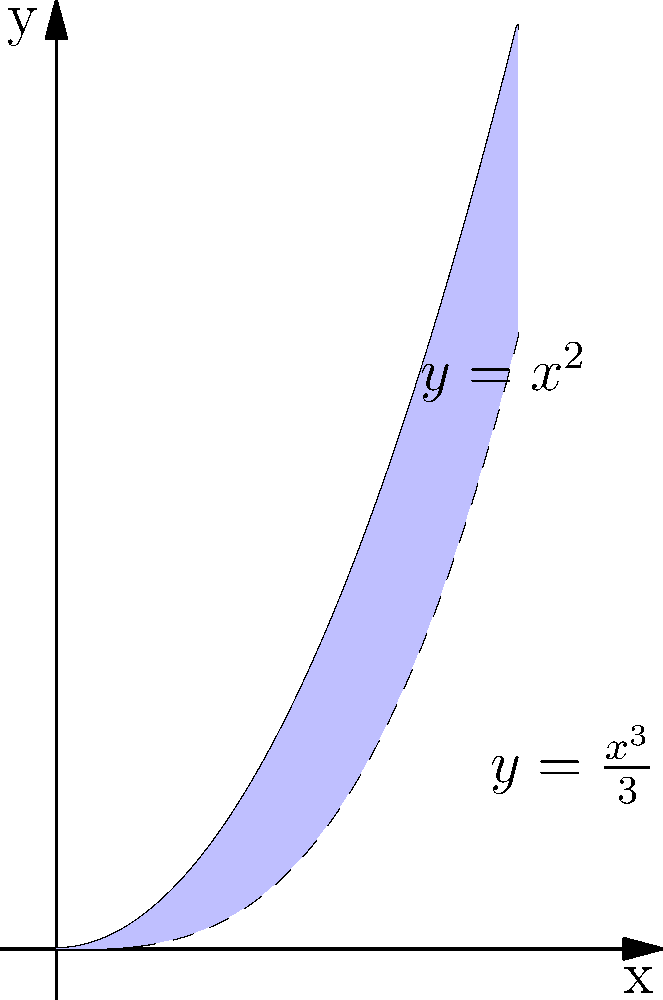As an NLP developer working on mathematical language processing, you're implementing a feature to compute areas between curves. Given the polynomial functions $f(x)=x^2$ and $g(x)=\frac{x^3}{3}$, calculate the area between these curves from $x=0$ to $x=2$. How would you approach this problem programmatically, and what is the resulting area? To find the area between two polynomial curves, we follow these steps:

1) Identify the upper and lower functions:
   $f(x) = x^2$ (upper function)
   $g(x) = \frac{x^3}{3}$ (lower function)

2) Set up the integral:
   Area = $\int_0^2 [f(x) - g(x)] dx$

3) Substitute the functions:
   Area = $\int_0^2 [x^2 - \frac{x^3}{3}] dx$

4) Integrate:
   Area = $[\frac{x^3}{3} - \frac{x^4}{12}]_0^2$

5) Evaluate the integral:
   Area = $[(\frac{2^3}{3} - \frac{2^4}{12}) - (0 - 0)]$
        = $[\frac{8}{3} - \frac{16}{12}]$
        = $\frac{32}{12} - \frac{16}{12}$
        = $\frac{16}{12}$
        = $\frac{4}{3}$

Programmatically, you would:
1. Define functions for $f(x)$ and $g(x)$
2. Implement a numerical integration method (e.g., Simpson's rule)
3. Apply the integration method to $f(x) - g(x)$ over the interval $[0, 2]$
Answer: $\frac{4}{3}$ square units 